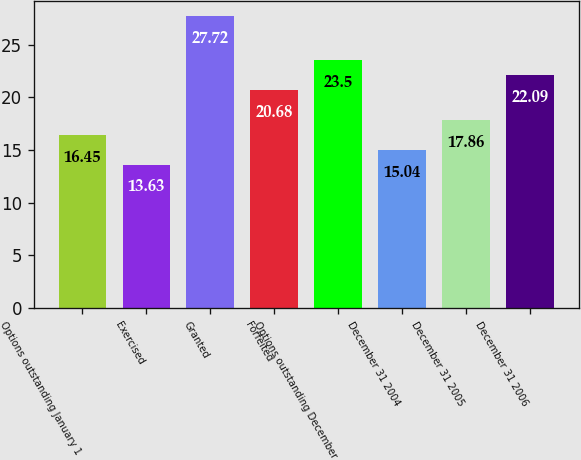Convert chart. <chart><loc_0><loc_0><loc_500><loc_500><bar_chart><fcel>Options outstanding January 1<fcel>Exercised<fcel>Granted<fcel>Forfeited<fcel>Options outstanding December<fcel>December 31 2004<fcel>December 31 2005<fcel>December 31 2006<nl><fcel>16.45<fcel>13.63<fcel>27.72<fcel>20.68<fcel>23.5<fcel>15.04<fcel>17.86<fcel>22.09<nl></chart> 